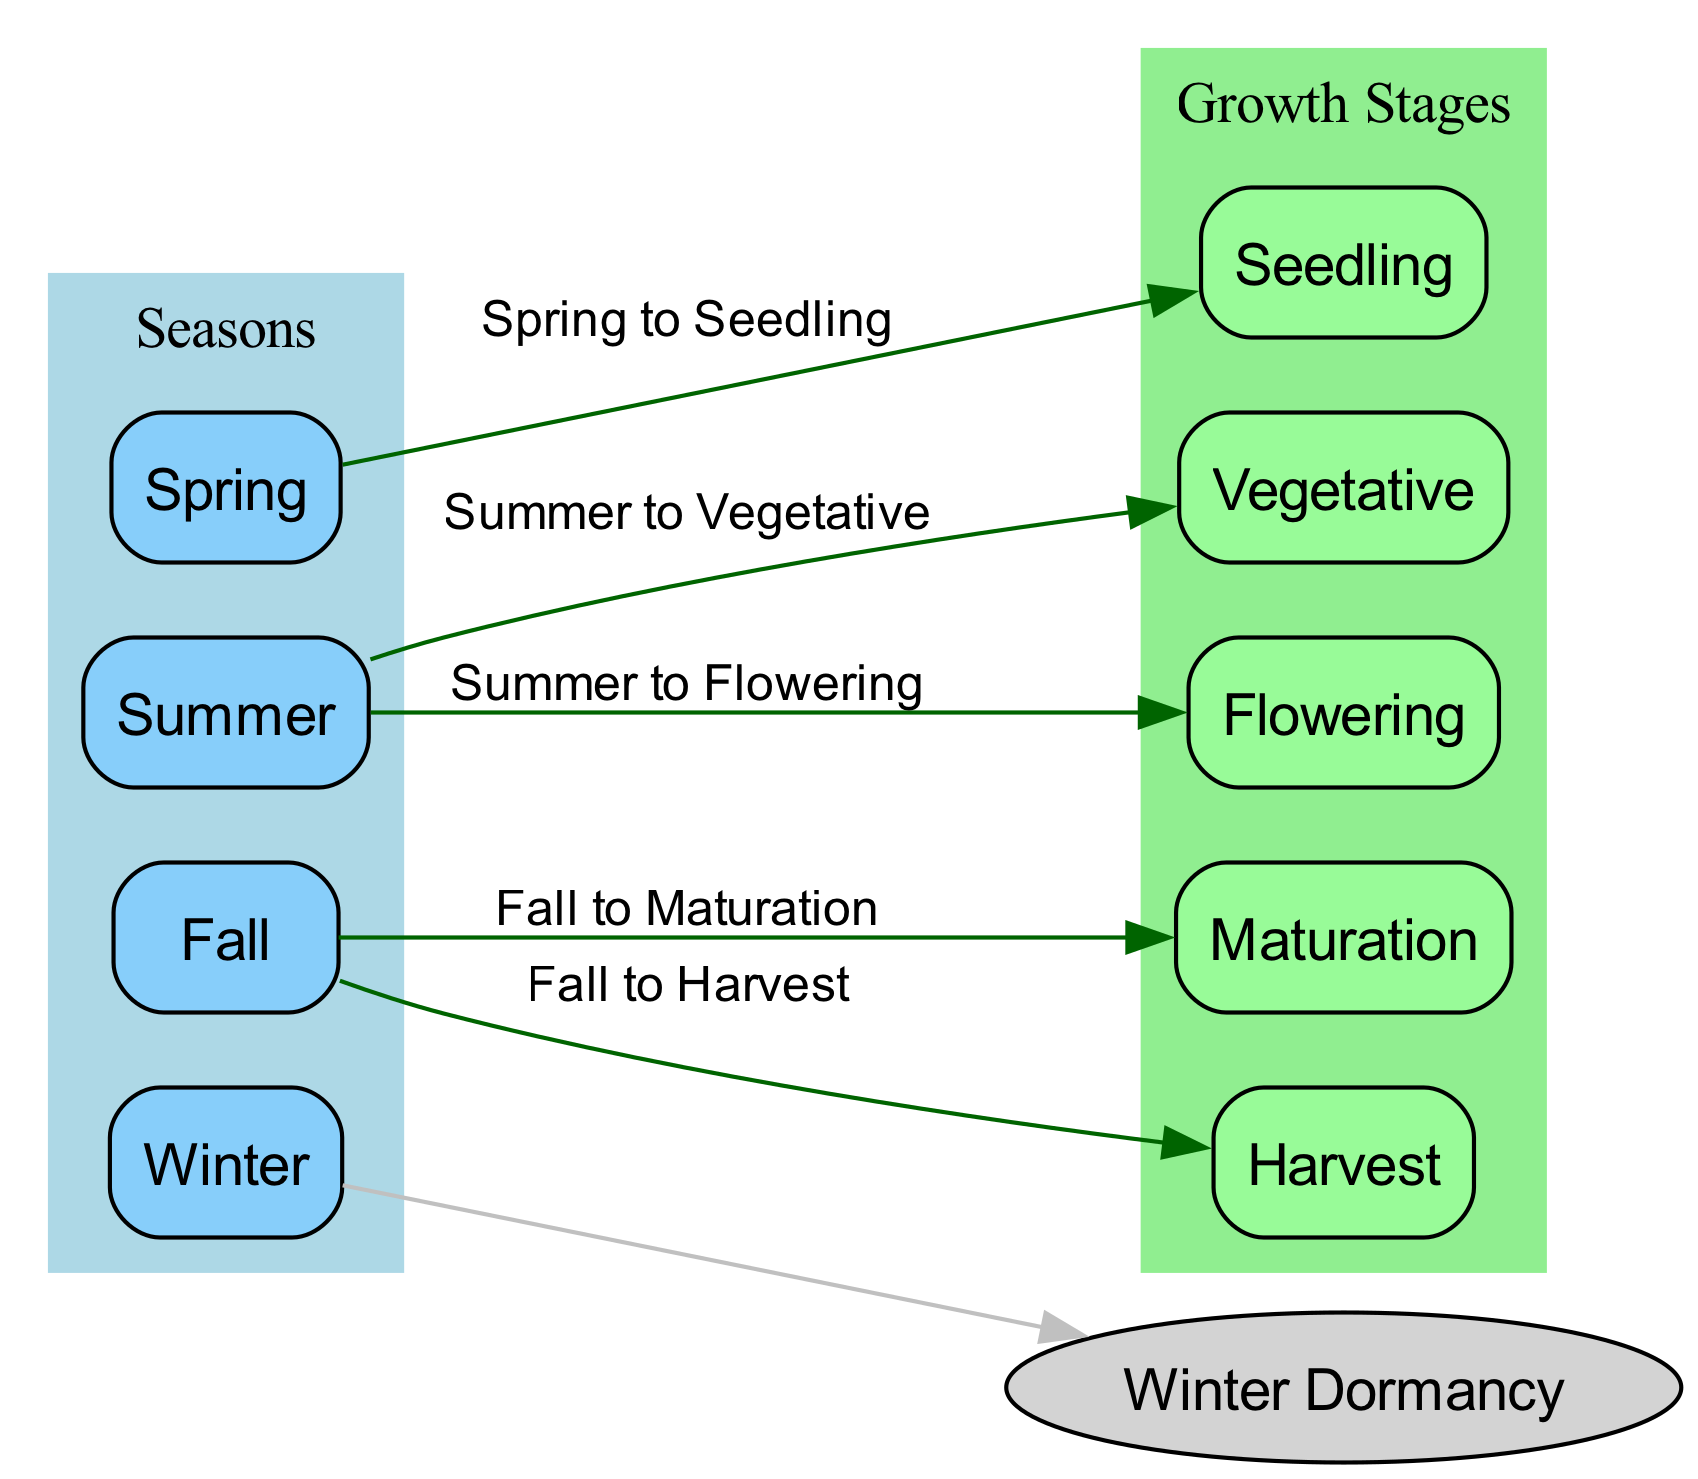What is the first growth stage in spring? The diagram shows an edge from "Spring" to "Seedling," indicating that "Seedling" is the first growth stage during spring.
Answer: Seedling How many seasons are represented in the diagram? The diagram lists four nodes labeled as seasons: Spring, Summer, Fall, and Winter, which totals to four seasons.
Answer: Four Which growth stage corresponds to summer? The edges originating from "Summer" lead to two growth stages: "Vegetative" and "Flowering," thus both are the growth stages corresponding to summer.
Answer: Vegetative, Flowering What growth stage follows fall? The edges connect "Fall" to "Maturation" and "Harvest," indicating that after fall, the growth stages are "Maturation" and "Harvest."
Answer: Maturation, Harvest During which season do plants undergo dormancy? The diagram specifically mentions "Winter Dormancy," implying that the plants undergo dormancy in winter.
Answer: Winter How many growth stages are there in total? The diagram includes five growth stages: Seedling, Vegetative, Flowering, Maturation, and Harvest, resulting in a total of five growth stages.
Answer: Five What is the last stage of crop growth in fall? The edge from "Fall" directly leads to "Harvest," indicating that "Harvest" is the last stage of crop growth in fall.
Answer: Harvest Which growth stage occurs after the vegetative stage? The diagram shows that "Vegetative" is followed by "Flowering," thus indicating that "Flowering" occurs after "Vegetative."
Answer: Flowering What connects summer to the flowering stage? The edge labeled "Summer to Flowering" directly connects the summer season to the flowering growth stage in the diagram.
Answer: Summer to Flowering 